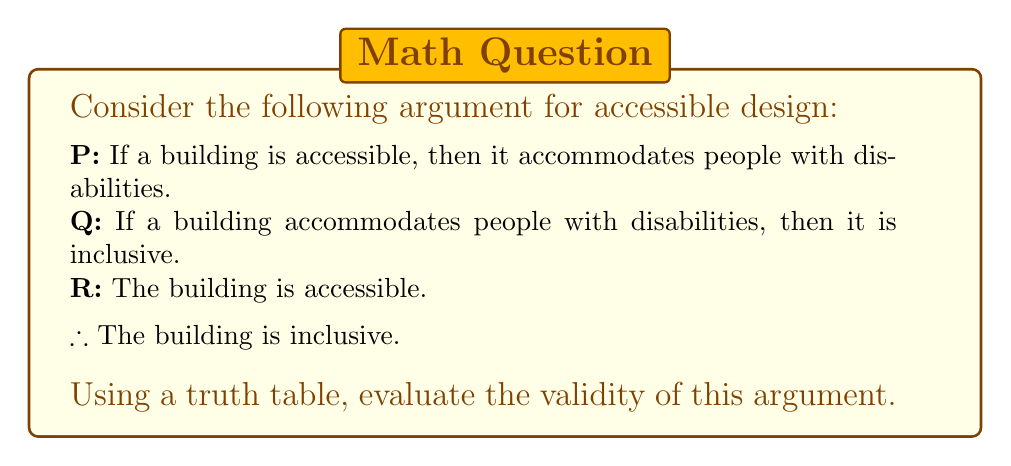Teach me how to tackle this problem. To evaluate the validity of this argument using a truth table, we need to follow these steps:

1. Identify the premises and conclusion:
   Premise 1: $P \rightarrow Q$ (If a building is accessible, then it accommodates people with disabilities)
   Premise 2: $Q \rightarrow R$ (If a building accommodates people with disabilities, then it is inclusive)
   Premise 3: $P$ (The building is accessible)
   Conclusion: $R$ (The building is inclusive)

2. Construct the truth table:
   We need to include columns for P, Q, R, and the logical connectives used in the premises.

   $$ \begin{array}{|c|c|c|c|c|c|}
   \hline
   P & Q & R & P \rightarrow Q & Q \rightarrow R & (P \rightarrow Q) \land (Q \rightarrow R) \land P \\
   \hline
   T & T & T & T & T & T \\
   T & T & F & T & F & F \\
   T & F & T & F & T & F \\
   T & F & F & F & T & F \\
   F & T & T & T & T & F \\
   F & T & F & T & F & F \\
   F & F & T & T & T & F \\
   F & F & F & T & T & F \\
   \hline
   \end{array} $$

3. Analyze the truth table:
   - The argument is valid if, in every row where all premises are true, the conclusion is also true.
   - We can see that there is only one row (the first row) where all premises are true: $(P \rightarrow Q) \land (Q \rightarrow R) \land P$ is true.
   - In this row, we can see that the conclusion $R$ is also true.

4. Interpret the results:
   Since the conclusion is true in the only row where all premises are true, we can conclude that this argument is valid. This means that if all the premises are true, the conclusion must also be true.

In the context of accessible design, this logical argument supports the idea that making a building accessible leads to inclusivity, which is an important consideration for disability advocates.
Answer: The argument is valid. The truth table shows that when all premises are true, the conclusion is also true, indicating a logically valid argument for accessible design leading to inclusivity. 